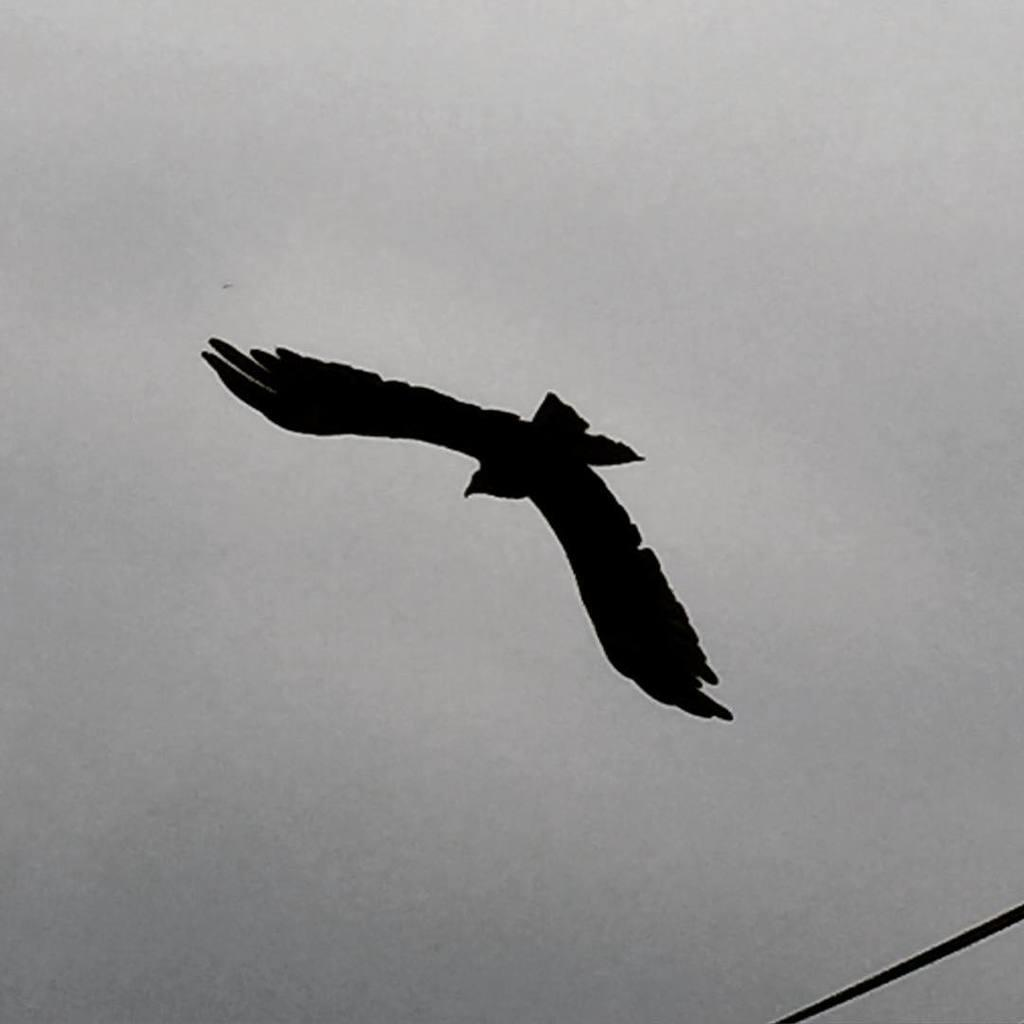What type of animal is in the image? There is a bird in the image. What color is the bird? The bird is black in color. What is the bird doing in the image? The bird is flying in the sky. What can be seen in the background of the image? The sky is visible in the background of the image. How many giraffes are in the picture? There are no giraffes present in the image; it features a black bird flying in the sky. What is the rate of the bird's flight in the image? The image does not provide information about the bird's flight rate. 